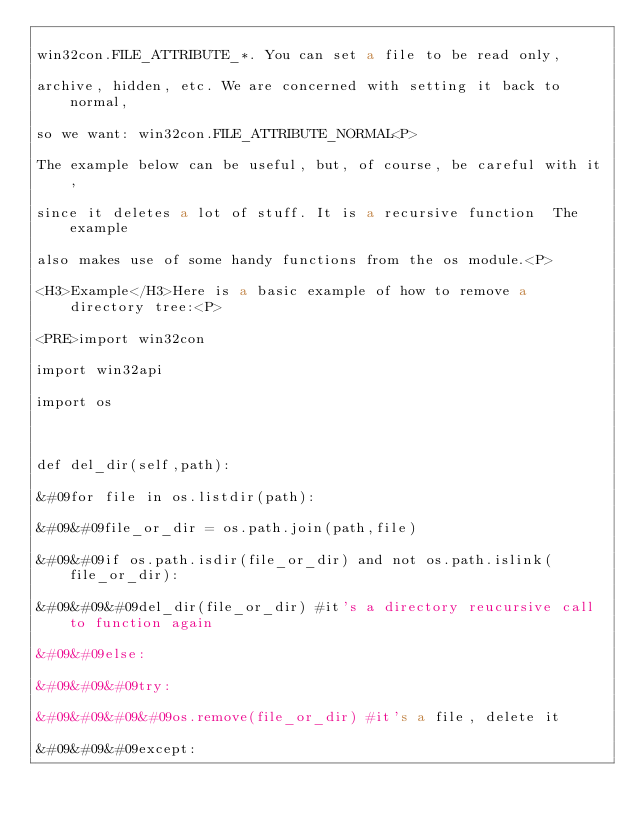<code> <loc_0><loc_0><loc_500><loc_500><_HTML_>
win32con.FILE_ATTRIBUTE_*. You can set a file to be read only, 

archive, hidden, etc. We are concerned with setting it back to normal, 

so we want: win32con.FILE_ATTRIBUTE_NORMAL<P>

The example below can be useful, but, of course, be careful with it, 

since it deletes a lot of stuff. It is a recursive function  The example 

also makes use of some handy functions from the os module.<P>

<H3>Example</H3>Here is a basic example of how to remove a directory tree:<P>

<PRE>import win32con

import win32api

import os



def del_dir(self,path):

&#09for file in os.listdir(path):

&#09&#09file_or_dir = os.path.join(path,file)

&#09&#09if os.path.isdir(file_or_dir) and not os.path.islink(file_or_dir):

&#09&#09&#09del_dir(file_or_dir) #it's a directory reucursive call to function again

&#09&#09else:

&#09&#09&#09try:

&#09&#09&#09&#09os.remove(file_or_dir) #it's a file, delete it

&#09&#09&#09except:
</code> 